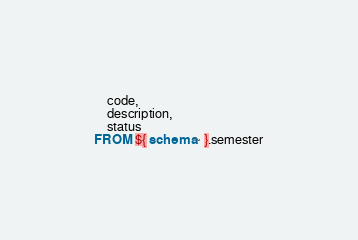Convert code to text. <code><loc_0><loc_0><loc_500><loc_500><_SQL_>    code,
    description,
    status
FROM ${ schema~ }.semester
</code> 